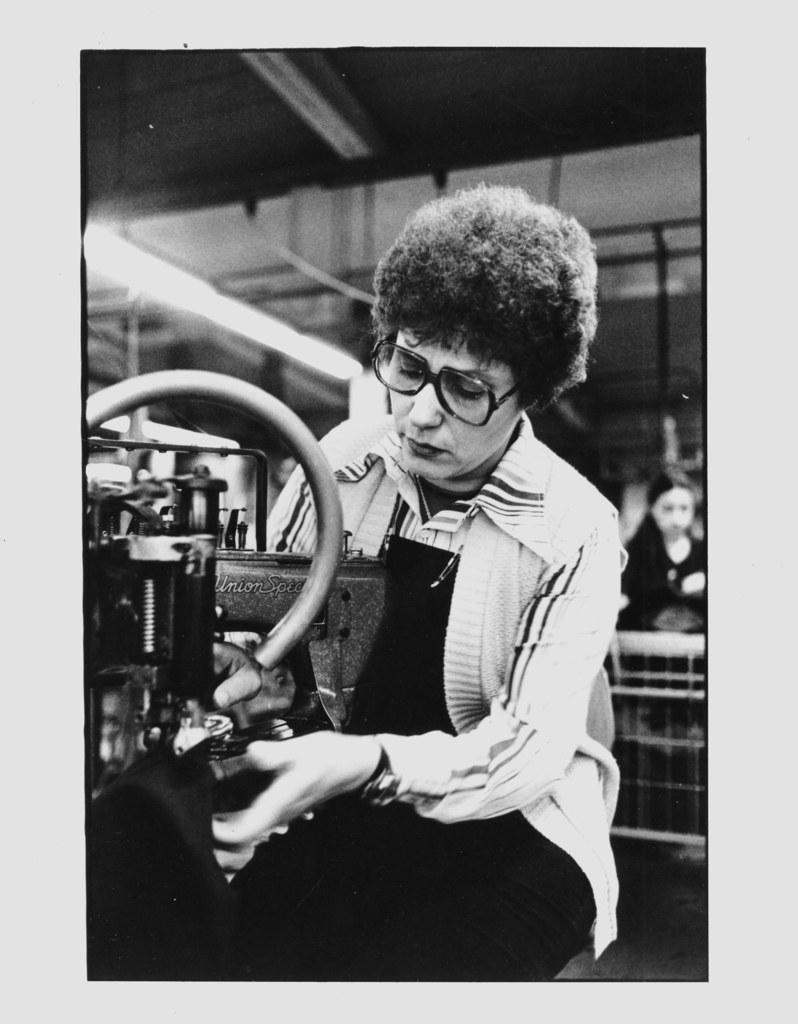What is the woman in the image doing? The woman is sitting in the image. What is the woman wearing? The woman is wearing clothes and spectacles. What can be seen in the background of the image? There is a machine and another woman behind the sitting woman. What is the source of illumination in the image? There is a light in the image. What surface is the woman sitting on? There is a floor in the image. What type of lumber is the queen using to build a castle in the image? There is no queen or lumber present in the image; it features a woman sitting with a machine and another woman in the background. 